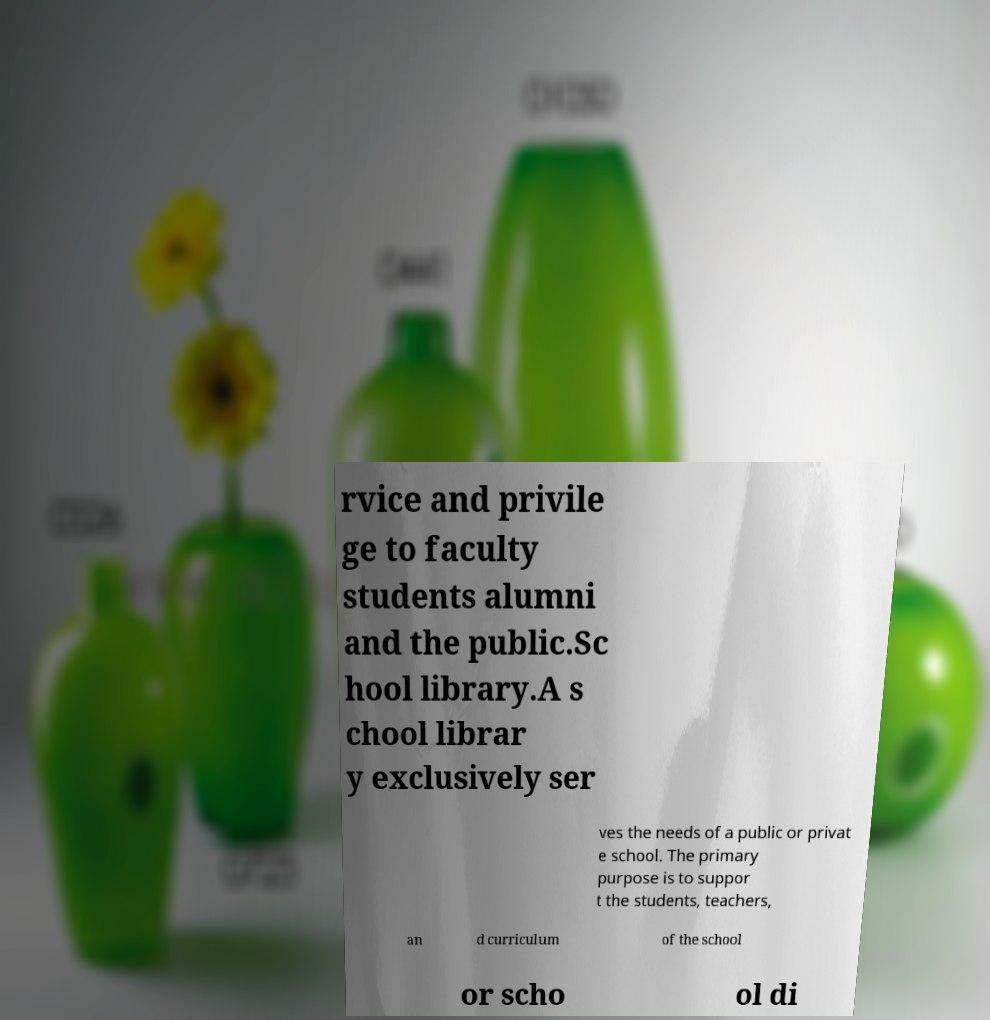For documentation purposes, I need the text within this image transcribed. Could you provide that? rvice and privile ge to faculty students alumni and the public.Sc hool library.A s chool librar y exclusively ser ves the needs of a public or privat e school. The primary purpose is to suppor t the students, teachers, an d curriculum of the school or scho ol di 